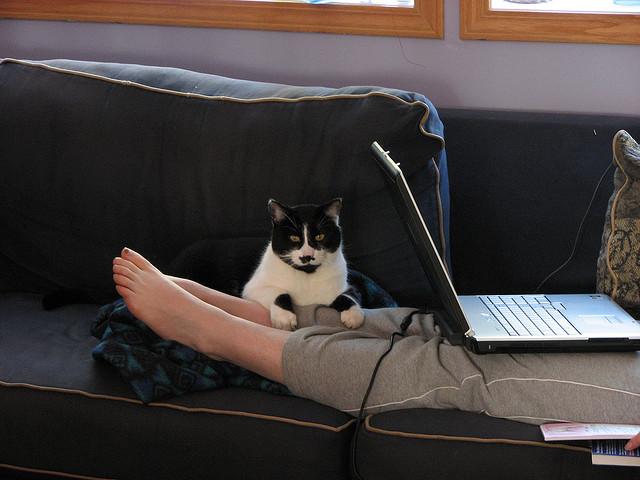What color are the cat's eyes?
Short answer required. Yellow. What color is the chair the cat is sitting on?
Short answer required. Black. What is the cat leaning on?
Short answer required. Leg. Who owns who?
Short answer required. Woman owns cat. 